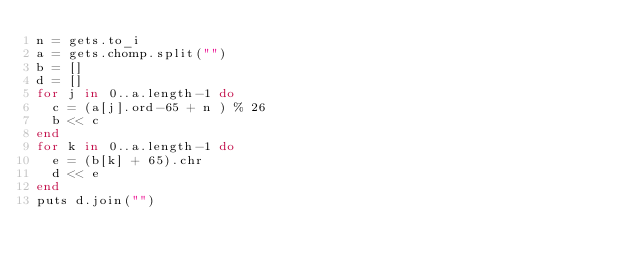Convert code to text. <code><loc_0><loc_0><loc_500><loc_500><_Ruby_>n = gets.to_i
a = gets.chomp.split("")
b = []
d = []
for j in 0..a.length-1 do
  c = (a[j].ord-65 + n ) % 26
  b << c
end
for k in 0..a.length-1 do
  e = (b[k] + 65).chr
  d << e
end
puts d.join("")</code> 